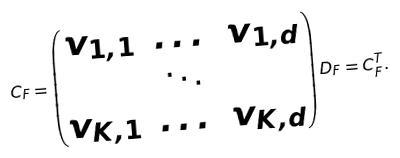<formula> <loc_0><loc_0><loc_500><loc_500>C _ { F } = \begin{pmatrix} v _ { 1 , 1 } & \dots & v _ { 1 , d } \\ & \ddots & \\ v _ { K , 1 } & \dots & v _ { K , d } \end{pmatrix} D _ { F } = C _ { F } ^ { T } .</formula> 